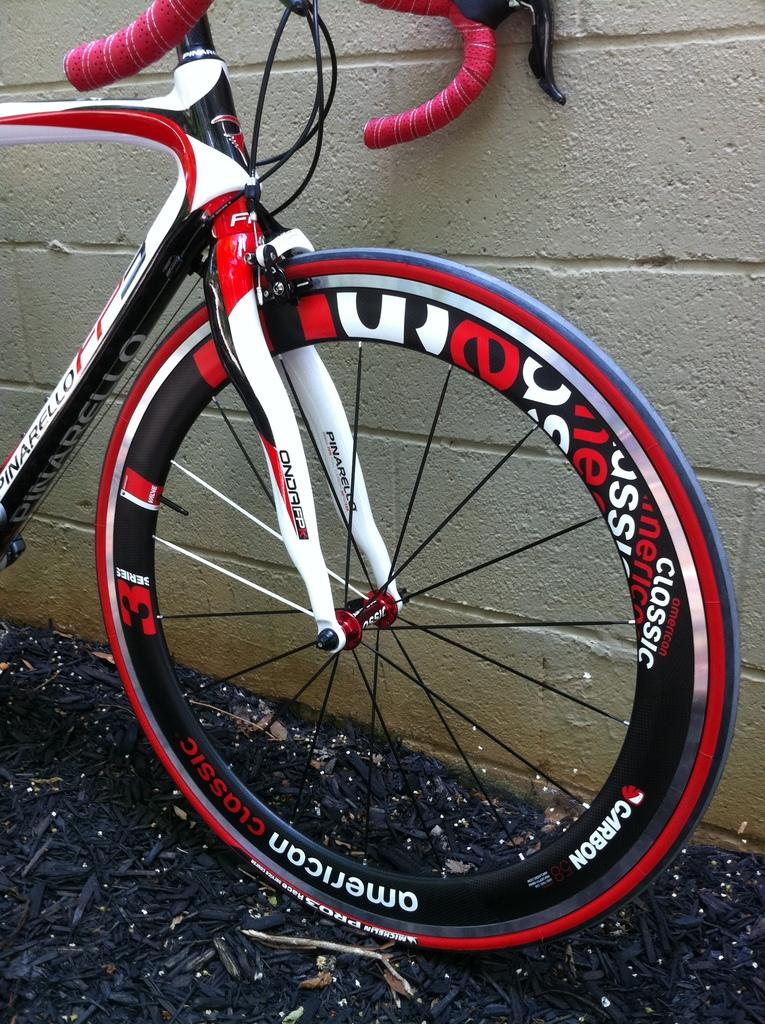What is the main object in the image? There is a bicycle in the image. Where is the bicycle located in relation to other objects? The bicycle is near a wall. What can be seen at the bottom of the image? There are black color sticks at the bottom of the image. What nation is represented by the bicycle in the image? The image does not depict a specific nation, and the bicycle itself does not represent a nation. 